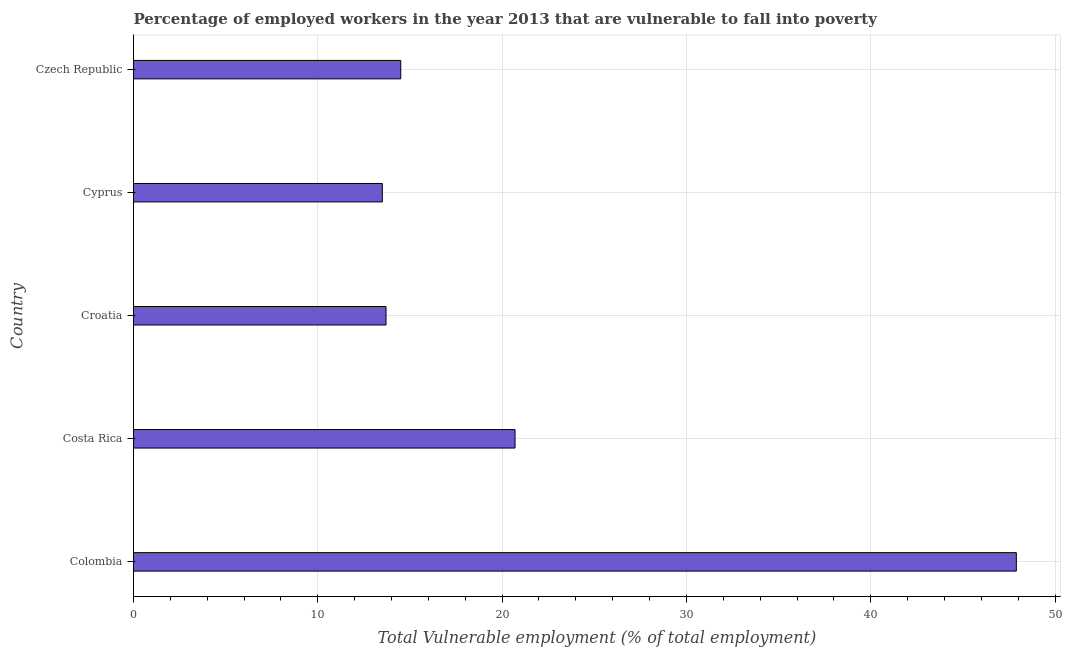Does the graph contain any zero values?
Make the answer very short. No. What is the title of the graph?
Provide a succinct answer. Percentage of employed workers in the year 2013 that are vulnerable to fall into poverty. What is the label or title of the X-axis?
Offer a terse response. Total Vulnerable employment (% of total employment). What is the label or title of the Y-axis?
Offer a very short reply. Country. What is the total vulnerable employment in Cyprus?
Keep it short and to the point. 13.5. Across all countries, what is the maximum total vulnerable employment?
Keep it short and to the point. 47.9. In which country was the total vulnerable employment maximum?
Your response must be concise. Colombia. In which country was the total vulnerable employment minimum?
Give a very brief answer. Cyprus. What is the sum of the total vulnerable employment?
Your answer should be compact. 110.3. What is the difference between the total vulnerable employment in Colombia and Czech Republic?
Your response must be concise. 33.4. What is the average total vulnerable employment per country?
Your answer should be very brief. 22.06. What is the ratio of the total vulnerable employment in Croatia to that in Cyprus?
Offer a very short reply. 1.01. What is the difference between the highest and the second highest total vulnerable employment?
Provide a succinct answer. 27.2. Is the sum of the total vulnerable employment in Cyprus and Czech Republic greater than the maximum total vulnerable employment across all countries?
Your answer should be very brief. No. What is the difference between the highest and the lowest total vulnerable employment?
Offer a terse response. 34.4. In how many countries, is the total vulnerable employment greater than the average total vulnerable employment taken over all countries?
Make the answer very short. 1. How many bars are there?
Offer a terse response. 5. Are all the bars in the graph horizontal?
Offer a terse response. Yes. How many countries are there in the graph?
Offer a very short reply. 5. What is the Total Vulnerable employment (% of total employment) of Colombia?
Your response must be concise. 47.9. What is the Total Vulnerable employment (% of total employment) of Costa Rica?
Your answer should be very brief. 20.7. What is the Total Vulnerable employment (% of total employment) of Croatia?
Your answer should be very brief. 13.7. What is the Total Vulnerable employment (% of total employment) in Cyprus?
Your answer should be very brief. 13.5. What is the difference between the Total Vulnerable employment (% of total employment) in Colombia and Costa Rica?
Your response must be concise. 27.2. What is the difference between the Total Vulnerable employment (% of total employment) in Colombia and Croatia?
Offer a terse response. 34.2. What is the difference between the Total Vulnerable employment (% of total employment) in Colombia and Cyprus?
Ensure brevity in your answer.  34.4. What is the difference between the Total Vulnerable employment (% of total employment) in Colombia and Czech Republic?
Offer a very short reply. 33.4. What is the difference between the Total Vulnerable employment (% of total employment) in Costa Rica and Cyprus?
Provide a short and direct response. 7.2. What is the difference between the Total Vulnerable employment (% of total employment) in Costa Rica and Czech Republic?
Provide a short and direct response. 6.2. What is the difference between the Total Vulnerable employment (% of total employment) in Croatia and Cyprus?
Offer a very short reply. 0.2. What is the ratio of the Total Vulnerable employment (% of total employment) in Colombia to that in Costa Rica?
Offer a terse response. 2.31. What is the ratio of the Total Vulnerable employment (% of total employment) in Colombia to that in Croatia?
Offer a very short reply. 3.5. What is the ratio of the Total Vulnerable employment (% of total employment) in Colombia to that in Cyprus?
Ensure brevity in your answer.  3.55. What is the ratio of the Total Vulnerable employment (% of total employment) in Colombia to that in Czech Republic?
Offer a very short reply. 3.3. What is the ratio of the Total Vulnerable employment (% of total employment) in Costa Rica to that in Croatia?
Your answer should be very brief. 1.51. What is the ratio of the Total Vulnerable employment (% of total employment) in Costa Rica to that in Cyprus?
Make the answer very short. 1.53. What is the ratio of the Total Vulnerable employment (% of total employment) in Costa Rica to that in Czech Republic?
Keep it short and to the point. 1.43. What is the ratio of the Total Vulnerable employment (% of total employment) in Croatia to that in Cyprus?
Your response must be concise. 1.01. What is the ratio of the Total Vulnerable employment (% of total employment) in Croatia to that in Czech Republic?
Give a very brief answer. 0.94. What is the ratio of the Total Vulnerable employment (% of total employment) in Cyprus to that in Czech Republic?
Offer a very short reply. 0.93. 